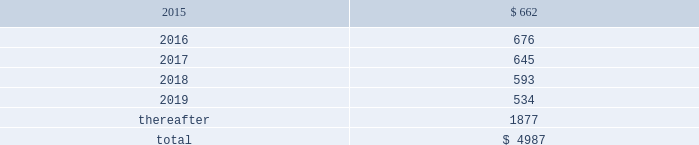Table of contents concentrations in the available sources of supply of materials and product although most components essential to the company 2019s business are generally available from multiple sources , a number of components are currently obtained from single or limited sources .
In addition , the company competes for various components with other participants in the markets for mobile communication and media devices and personal computers .
Therefore , many components used by the company , including those that are available from multiple sources , are at times subject to industry-wide shortage and significant pricing fluctuations that could materially adversely affect the company 2019s financial condition and operating results .
The company uses some custom components that are not commonly used by its competitors , and new products introduced by the company often utilize custom components available from only one source .
When a component or product uses new technologies , initial capacity constraints may exist until the suppliers 2019 yields have matured or manufacturing capacity has increased .
If the company 2019s supply of components for a new or existing product were delayed or constrained , or if an outsourcing partner delayed shipments of completed products to the company , the company 2019s financial condition and operating results could be materially adversely affected .
The company 2019s business and financial performance could also be materially adversely affected depending on the time required to obtain sufficient quantities from the original source , or to identify and obtain sufficient quantities from an alternative source .
Continued availability of these components at acceptable prices , or at all , may be affected if those suppliers concentrated on the production of common components instead of components customized to meet the company 2019s requirements .
The company has entered into agreements for the supply of many components ; however , there can be no guarantee that the company will be able to extend or renew these agreements on similar terms , or at all .
Therefore , the company remains subject to significant risks of supply shortages and price increases that could materially adversely affect its financial condition and operating results .
Substantially all of the company 2019s hardware products are manufactured by outsourcing partners that are located primarily in asia .
A significant concentration of this manufacturing is currently performed by a small number of outsourcing partners , often in single locations .
Certain of these outsourcing partners are the sole-sourced suppliers of components and manufacturers for many of the company 2019s products .
Although the company works closely with its outsourcing partners on manufacturing schedules , the company 2019s operating results could be adversely affected if its outsourcing partners were unable to meet their production commitments .
The company 2019s purchase commitments typically cover its requirements for periods up to 150 days .
Other off-balance sheet commitments operating leases the company leases various equipment and facilities , including retail space , under noncancelable operating lease arrangements .
The company does not currently utilize any other off-balance sheet financing arrangements .
The major facility leases are typically for terms not exceeding 10 years and generally contain multi-year renewal options .
Leases for retail space are for terms ranging from five to 20 years , the majority of which are for 10 years , and often contain multi-year renewal options .
As of september 27 , 2014 , the company 2019s total future minimum lease payments under noncancelable operating leases were $ 5.0 billion , of which $ 3.6 billion related to leases for retail space .
Rent expense under all operating leases , including both cancelable and noncancelable leases , was $ 717 million , $ 645 million and $ 488 million in 2014 , 2013 and 2012 , respectively .
Future minimum lease payments under noncancelable operating leases having remaining terms in excess of one year as of september 27 , 2014 , are as follows ( in millions ) : apple inc .
| 2014 form 10-k | 75 .

As of september 27 , 2014 , what percentage of the company 2019s total future minimum lease payments under noncancelable operating leases related to leases for retail space? 
Computations: (3.6 / 5)
Answer: 0.72. 